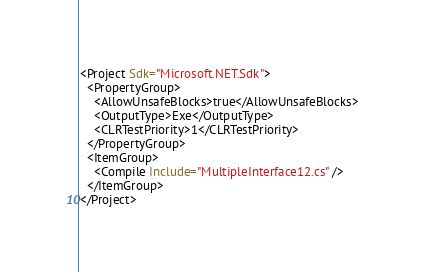<code> <loc_0><loc_0><loc_500><loc_500><_XML_><Project Sdk="Microsoft.NET.Sdk">
  <PropertyGroup>
    <AllowUnsafeBlocks>true</AllowUnsafeBlocks>
    <OutputType>Exe</OutputType>
    <CLRTestPriority>1</CLRTestPriority>
  </PropertyGroup>
  <ItemGroup>
    <Compile Include="MultipleInterface12.cs" />
  </ItemGroup>
</Project>
</code> 